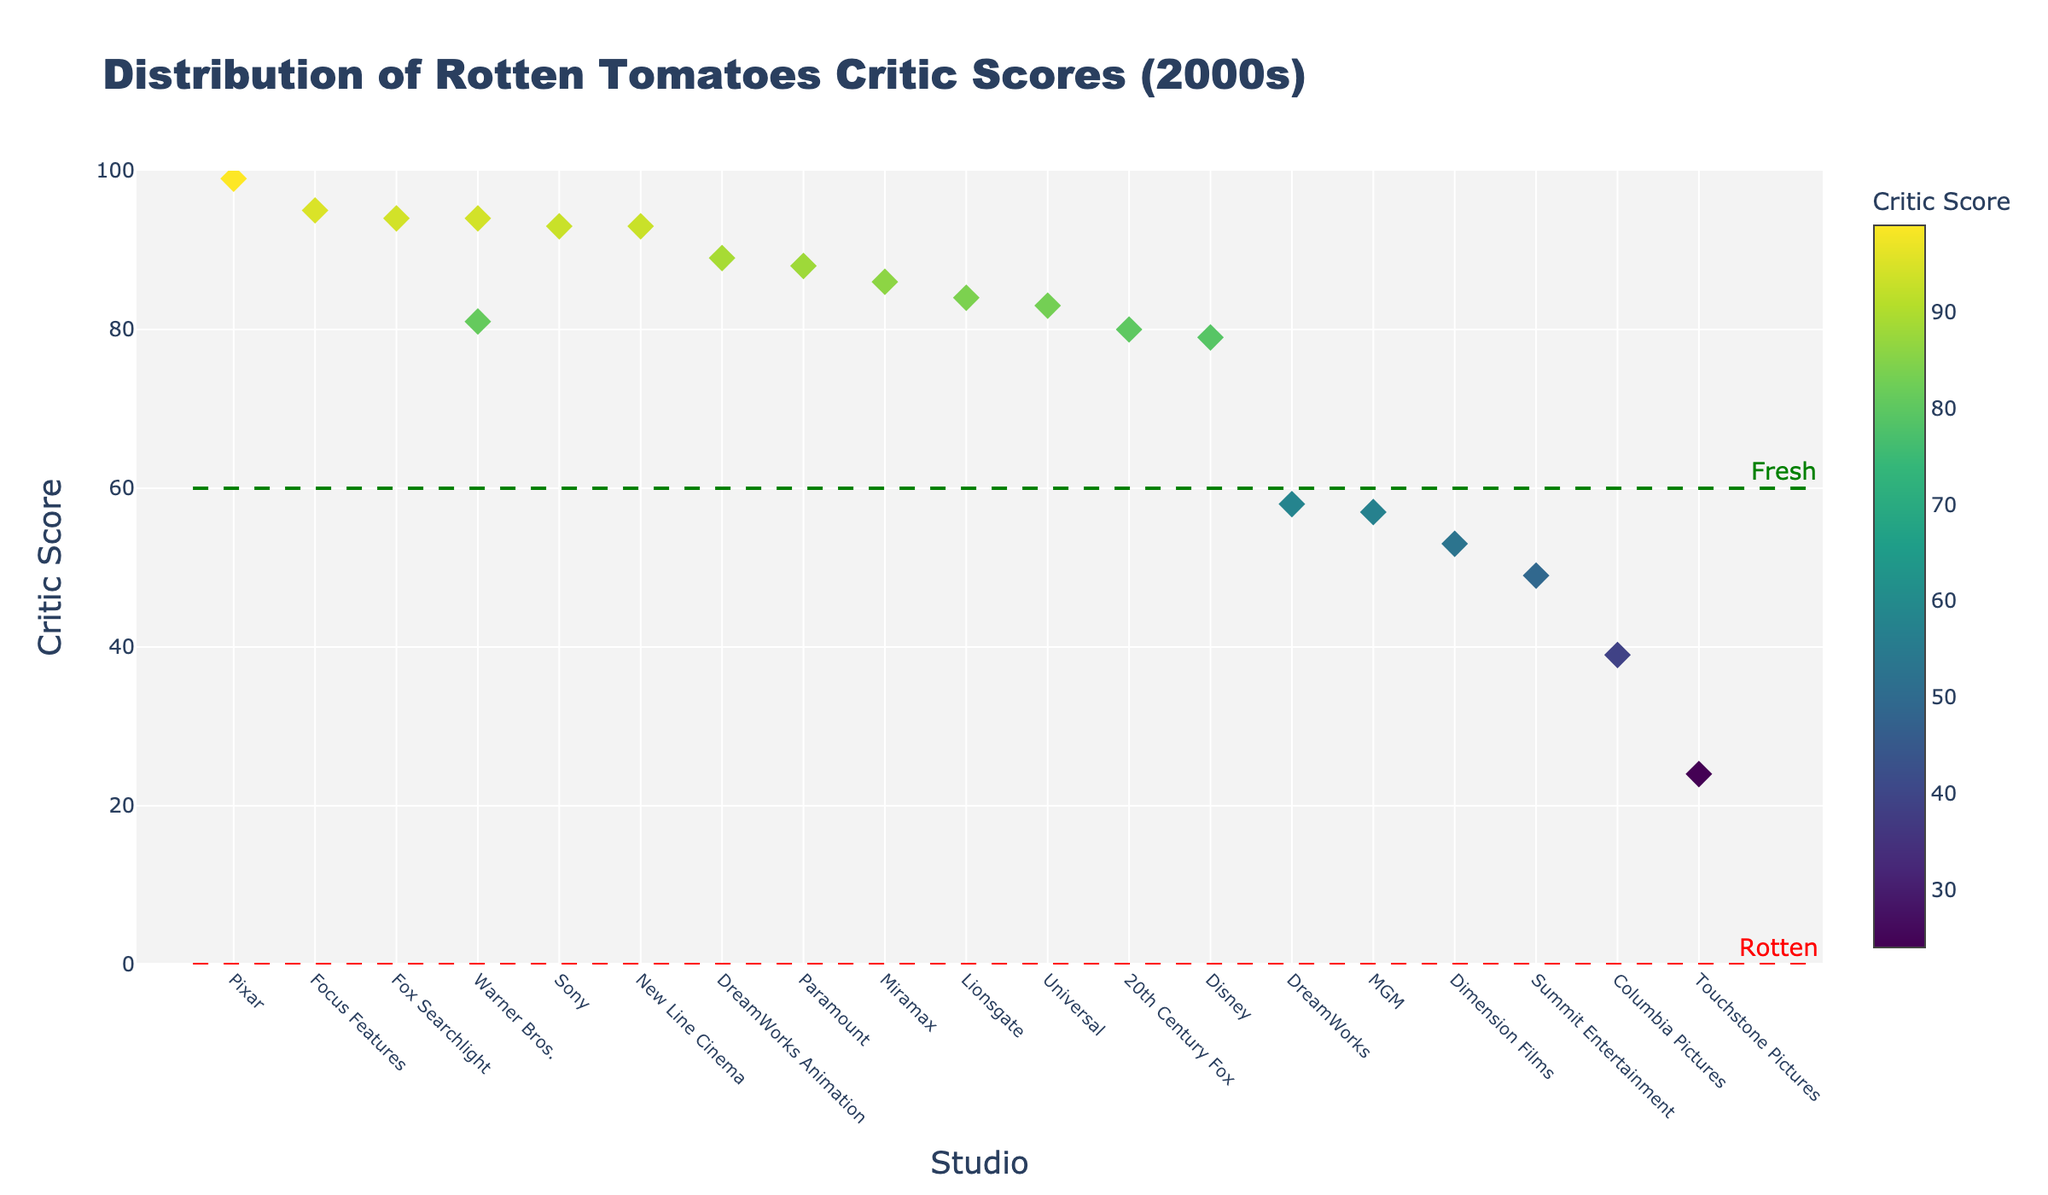Which studio has the highest critic score? The highest point on the y-axis represents the highest critic score, which corresponds to the marker for Pixar with a score of 99 for "Finding Nemo".
Answer: Pixar What is the title of the plot? The title is prominently displayed at the top of the figure. It reads "Distribution of Rotten Tomatoes Critic Scores (2000s)".
Answer: Distribution of Rotten Tomatoes Critic Scores (2000s) Which year had the movie with the lowest critic score and which studio produced it? The lowest point on the y-axis indicates the movie with the lowest critic score. By checking the hover text, it shows "Pearl Harbor" made by Touchstone Pictures in 2001 with a score of 24.
Answer: 2001, Touchstone Pictures How many studios are presented in the plot? The plot has markers corresponding to different studios along the x-axis. Counting these, we see markers for 18 studios.
Answer: 18 What is the average critic score for the movies by DreamWorks and DreamWorks Animation? Both DreamWorks and DreamWorks Animation represent two markers. The critic scores are 58 (Transformers, 2007) and 89 (Shrek 2, 2004), so the average is (58 + 89) / 2 = 73.5.
Answer: 73.5 Which studio's movie had a critic score closest to 50 and what was the title? Looking at the y-axis and finding the critic score closest to 50, the marker aligns with "Twilight" by Summit Entertainment with a score of 49.
Answer: Summit Entertainment, Twilight Which studios have more than one movie listed in the plot? Upon visual inspection of the studios along the x-axis, Warner Bros. has two markers corresponding to "Harry Potter and the Sorcerer's Stone" (2001) and "The Dark Knight" (2008).
Answer: Warner Bros Compare the critic scores of "Spider-Man 2" and "Shrek 2". Which has a higher score and by how much? Identifying both movies' scores, "Spider-Man 2" has a score of 93, and "Shrek 2" has 89. The difference is 93 - 89 = 4.
Answer: Spider-Man 2 by 4 What is the range of critic scores on the plot? By inspecting the y-axis, the highest score is 99, and the lowest score is 24. The range is 99 - 24 = 75.
Answer: 75 How many movies have critic scores considered "Fresh" (above 60)? The "Fresh" and "Rotten" categories are marked by horizontal lines at the score of 60. Counting the markers above 60 shows there are 15 movies.
Answer: 15 